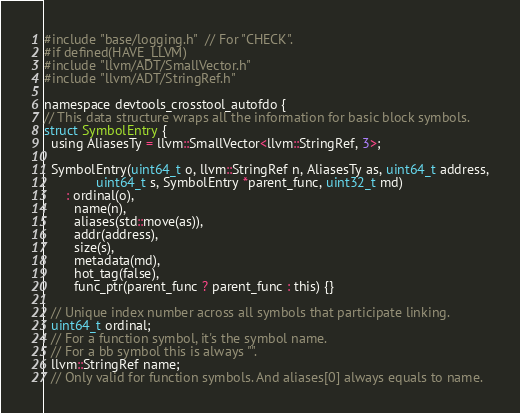Convert code to text. <code><loc_0><loc_0><loc_500><loc_500><_C_>#include "base/logging.h"  // For "CHECK".
#if defined(HAVE_LLVM)
#include "llvm/ADT/SmallVector.h"
#include "llvm/ADT/StringRef.h"

namespace devtools_crosstool_autofdo {
// This data structure wraps all the information for basic block symbols.
struct SymbolEntry {
  using AliasesTy = llvm::SmallVector<llvm::StringRef, 3>;

  SymbolEntry(uint64_t o, llvm::StringRef n, AliasesTy as, uint64_t address,
              uint64_t s, SymbolEntry *parent_func, uint32_t md)
      : ordinal(o),
        name(n),
        aliases(std::move(as)),
        addr(address),
        size(s),
        metadata(md),
        hot_tag(false),
        func_ptr(parent_func ? parent_func : this) {}

  // Unique index number across all symbols that participate linking.
  uint64_t ordinal;
  // For a function symbol, it's the symbol name.
  // For a bb symbol this is always "".
  llvm::StringRef name;
  // Only valid for function symbols. And aliases[0] always equals to name.</code> 